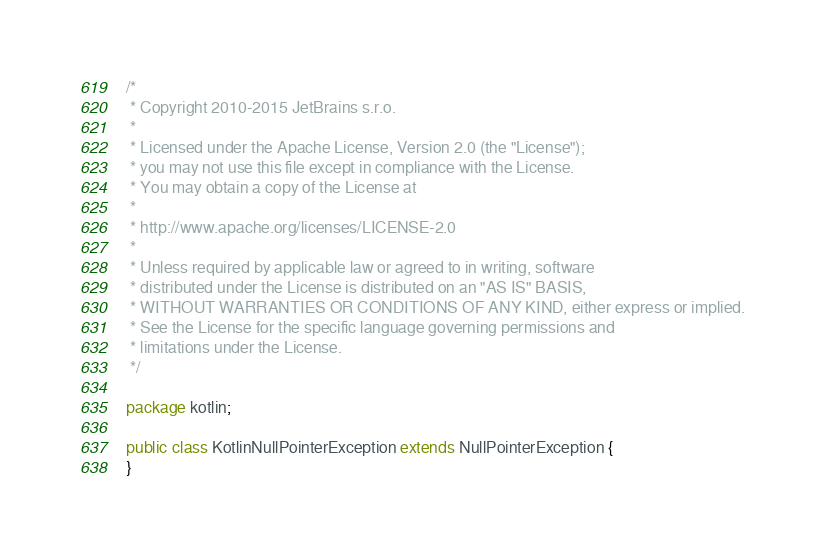<code> <loc_0><loc_0><loc_500><loc_500><_Java_>/*
 * Copyright 2010-2015 JetBrains s.r.o.
 *
 * Licensed under the Apache License, Version 2.0 (the "License");
 * you may not use this file except in compliance with the License.
 * You may obtain a copy of the License at
 *
 * http://www.apache.org/licenses/LICENSE-2.0
 *
 * Unless required by applicable law or agreed to in writing, software
 * distributed under the License is distributed on an "AS IS" BASIS,
 * WITHOUT WARRANTIES OR CONDITIONS OF ANY KIND, either express or implied.
 * See the License for the specific language governing permissions and
 * limitations under the License.
 */

package kotlin;

public class KotlinNullPointerException extends NullPointerException {
}
</code> 